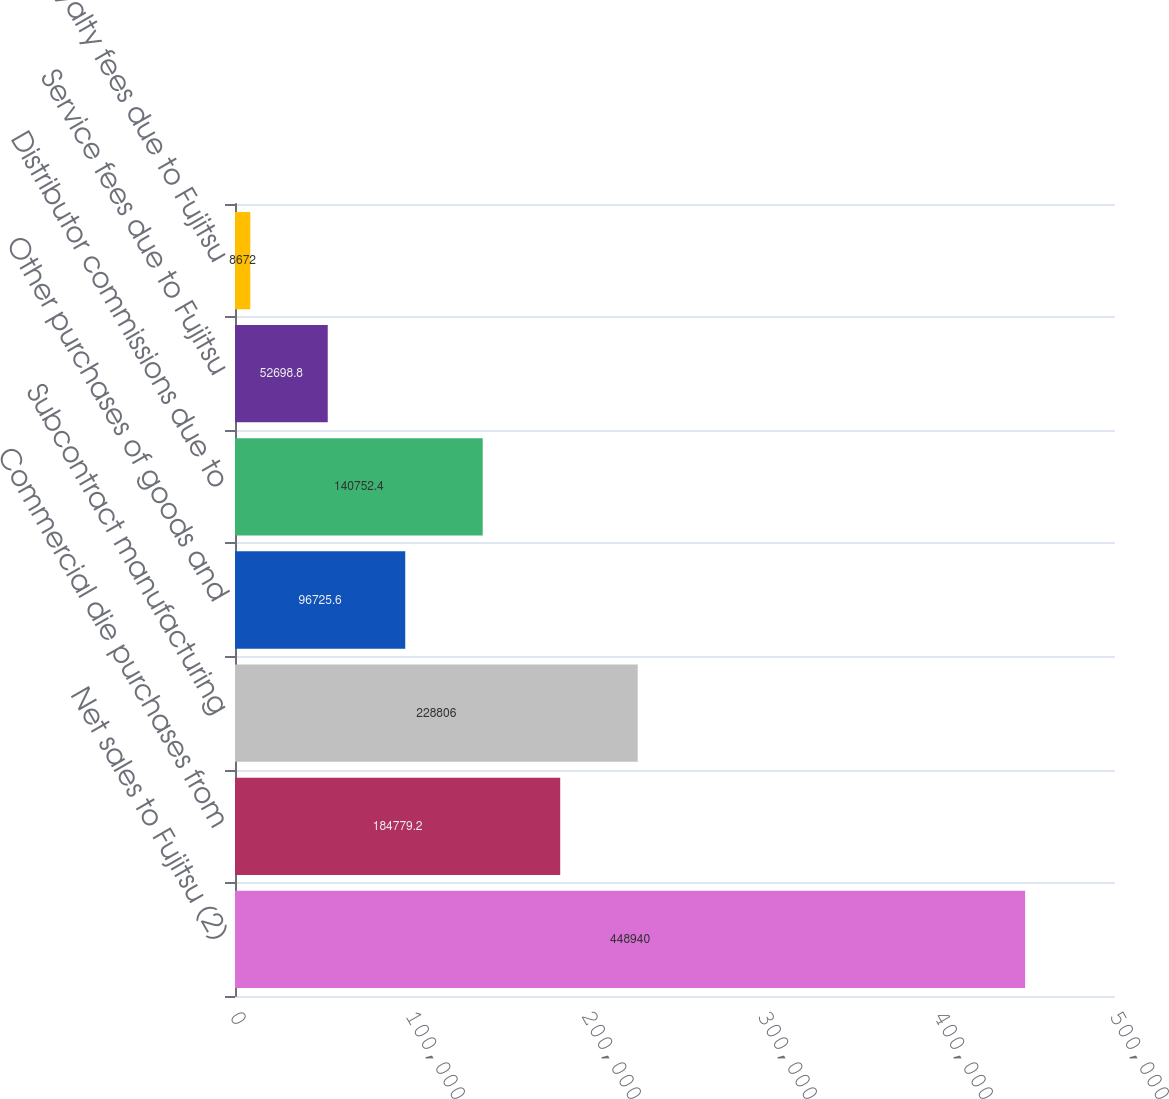Convert chart. <chart><loc_0><loc_0><loc_500><loc_500><bar_chart><fcel>Net sales to Fujitsu (2)<fcel>Commercial die purchases from<fcel>Subcontract manufacturing<fcel>Other purchases of goods and<fcel>Distributor commissions due to<fcel>Service fees due to Fujitsu<fcel>Royalty fees due to Fujitsu<nl><fcel>448940<fcel>184779<fcel>228806<fcel>96725.6<fcel>140752<fcel>52698.8<fcel>8672<nl></chart> 